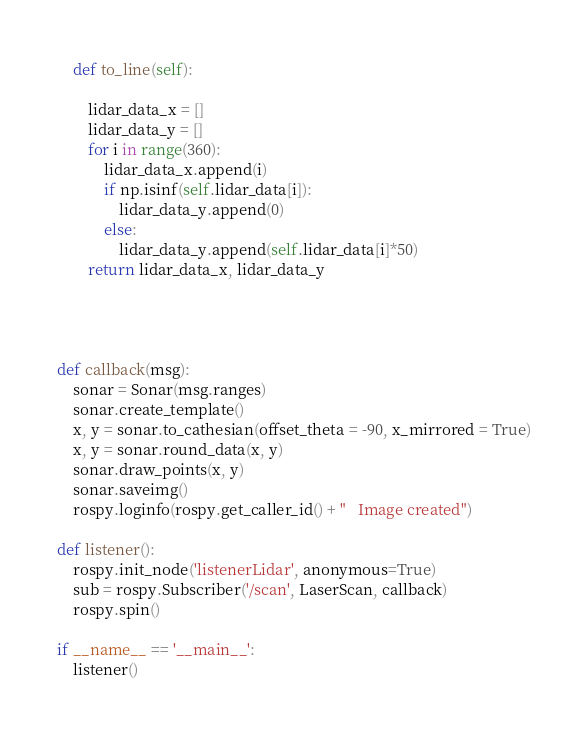Convert code to text. <code><loc_0><loc_0><loc_500><loc_500><_Python_>    def to_line(self):

        lidar_data_x = []
        lidar_data_y = []
        for i in range(360):
            lidar_data_x.append(i)
            if np.isinf(self.lidar_data[i]):
                lidar_data_y.append(0)
            else:
                lidar_data_y.append(self.lidar_data[i]*50)
        return lidar_data_x, lidar_data_y




def callback(msg):
    sonar = Sonar(msg.ranges)
    sonar.create_template()
    x, y = sonar.to_cathesian(offset_theta = -90, x_mirrored = True)
    x, y = sonar.round_data(x, y)
    sonar.draw_points(x, y)
    sonar.saveimg()
    rospy.loginfo(rospy.get_caller_id() + "   Image created")

def listener():
    rospy.init_node('listenerLidar', anonymous=True)
    sub = rospy.Subscriber('/scan', LaserScan, callback)
    rospy.spin()

if __name__ == '__main__':
    listener()
</code> 